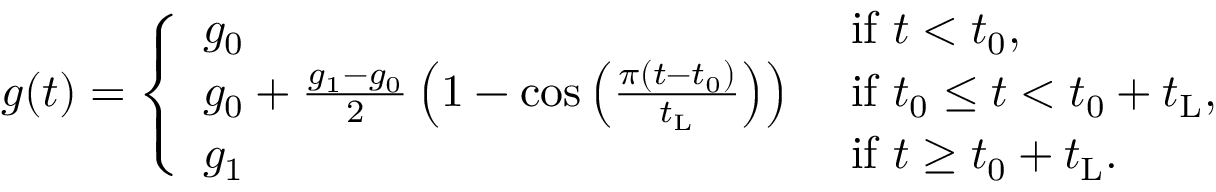<formula> <loc_0><loc_0><loc_500><loc_500>g ( t ) = \left \{ \begin{array} { l l } { g _ { 0 } } & { i f t < t _ { 0 } , } \\ { g _ { 0 } + \frac { g _ { 1 } - g _ { 0 } } { 2 } \left ( 1 - \cos \left ( \frac { \pi ( t - t _ { 0 } ) } { t _ { L } } \right ) \right ) } & { i f t _ { 0 } \leq t < t _ { 0 } + t _ { L } , } \\ { g _ { 1 } } & { i f t \geq t _ { 0 } + t _ { L } . } \end{array}</formula> 